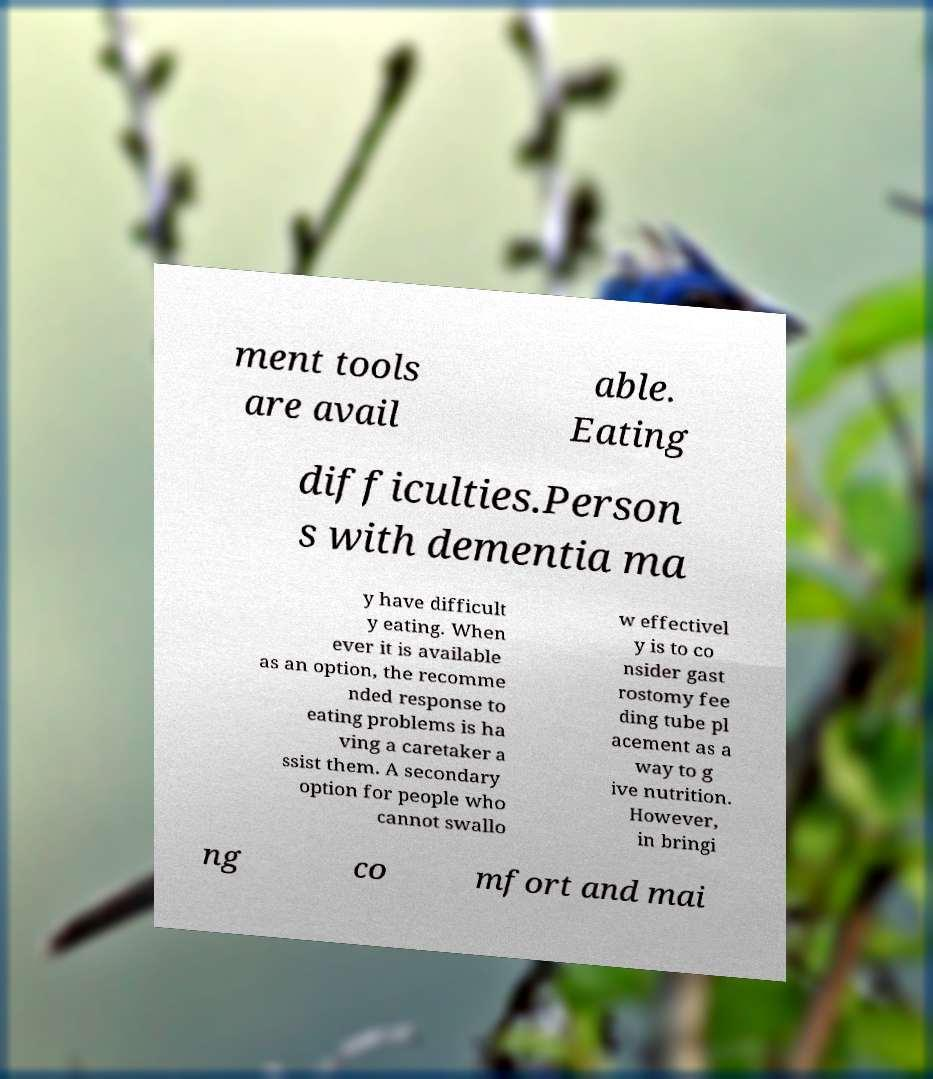I need the written content from this picture converted into text. Can you do that? ment tools are avail able. Eating difficulties.Person s with dementia ma y have difficult y eating. When ever it is available as an option, the recomme nded response to eating problems is ha ving a caretaker a ssist them. A secondary option for people who cannot swallo w effectivel y is to co nsider gast rostomy fee ding tube pl acement as a way to g ive nutrition. However, in bringi ng co mfort and mai 